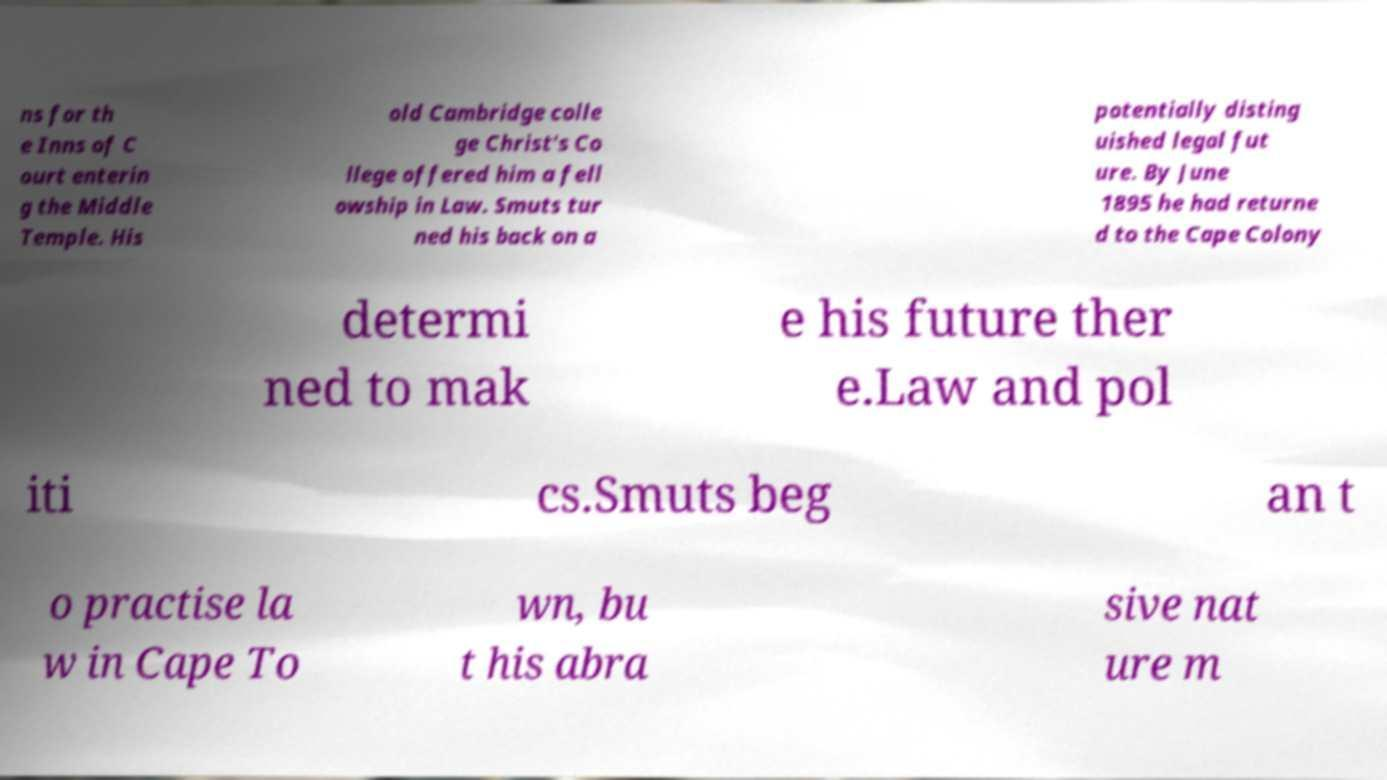What messages or text are displayed in this image? I need them in a readable, typed format. ns for th e Inns of C ourt enterin g the Middle Temple. His old Cambridge colle ge Christ's Co llege offered him a fell owship in Law. Smuts tur ned his back on a potentially disting uished legal fut ure. By June 1895 he had returne d to the Cape Colony determi ned to mak e his future ther e.Law and pol iti cs.Smuts beg an t o practise la w in Cape To wn, bu t his abra sive nat ure m 